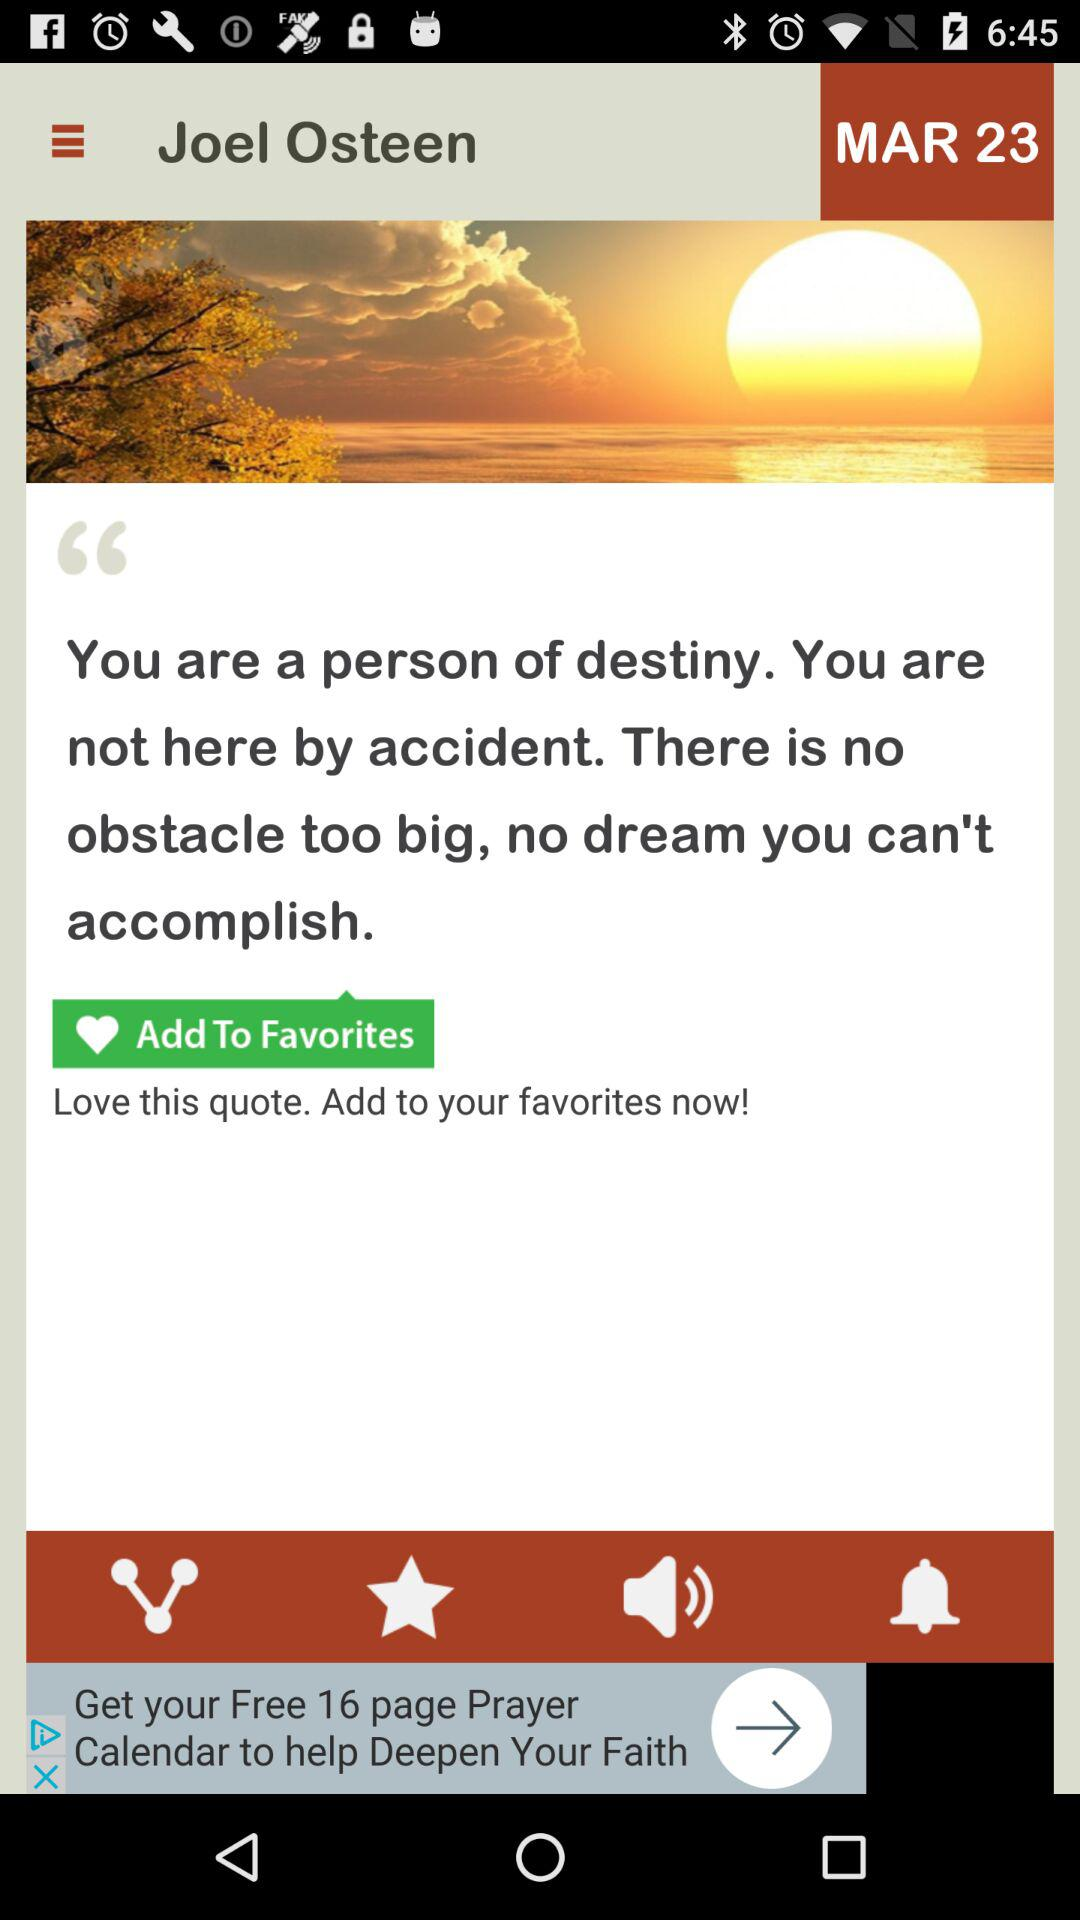What is the date shown on the screen? The date shown on the screen is March 23. 